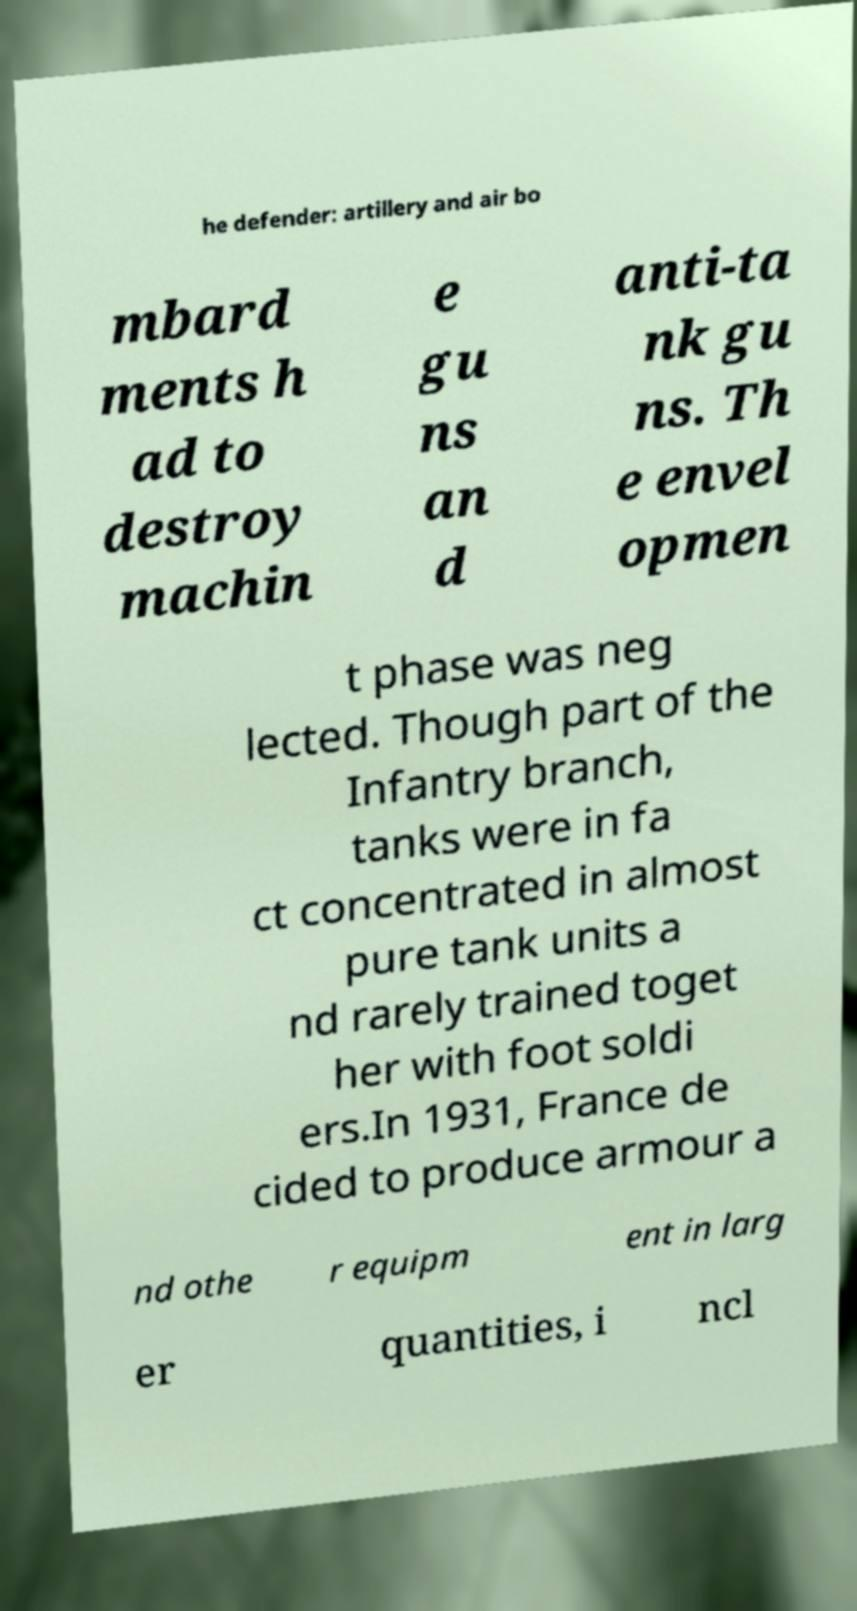Could you extract and type out the text from this image? he defender: artillery and air bo mbard ments h ad to destroy machin e gu ns an d anti-ta nk gu ns. Th e envel opmen t phase was neg lected. Though part of the Infantry branch, tanks were in fa ct concentrated in almost pure tank units a nd rarely trained toget her with foot soldi ers.In 1931, France de cided to produce armour a nd othe r equipm ent in larg er quantities, i ncl 